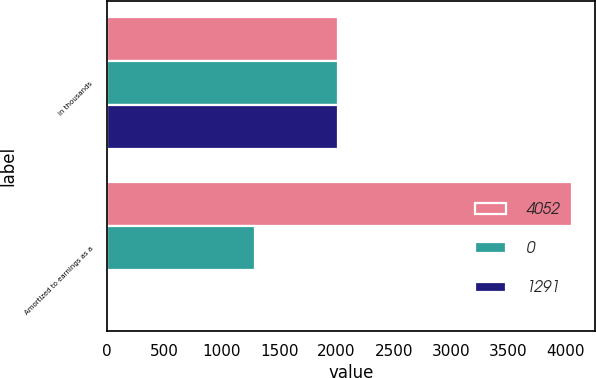Convert chart. <chart><loc_0><loc_0><loc_500><loc_500><stacked_bar_chart><ecel><fcel>in thousands<fcel>Amortized to earnings as a<nl><fcel>4052<fcel>2012<fcel>4052<nl><fcel>0<fcel>2011<fcel>1291<nl><fcel>1291<fcel>2010<fcel>0<nl></chart> 